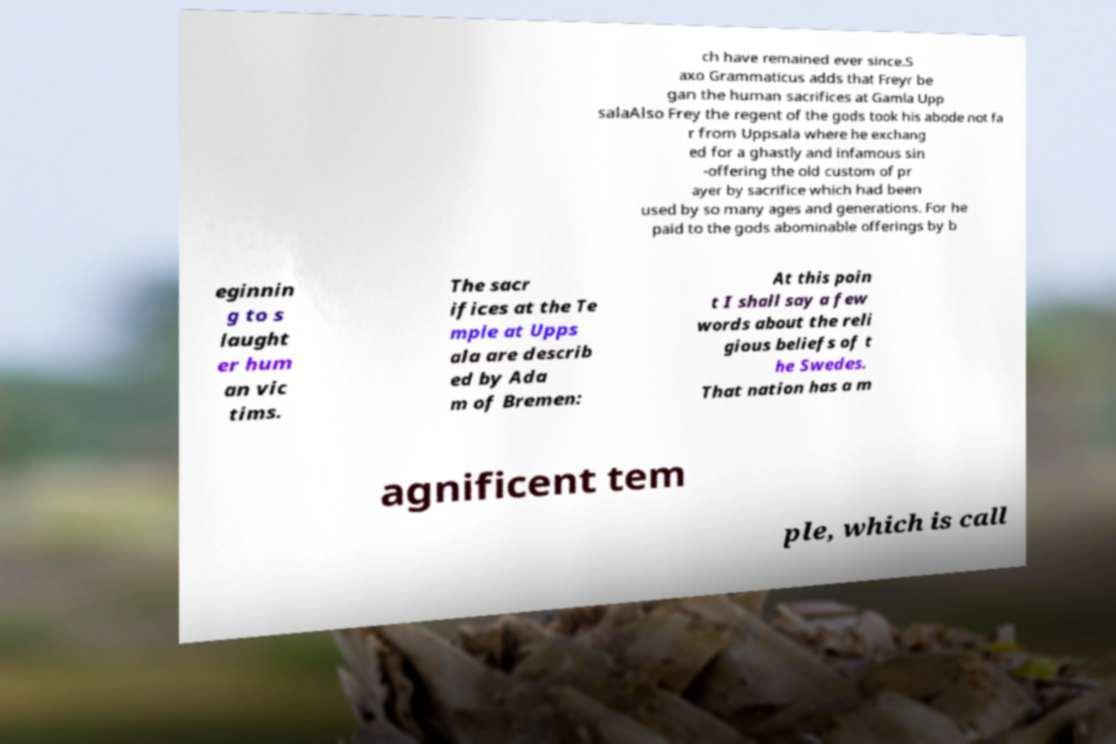Can you accurately transcribe the text from the provided image for me? ch have remained ever since.S axo Grammaticus adds that Freyr be gan the human sacrifices at Gamla Upp salaAlso Frey the regent of the gods took his abode not fa r from Uppsala where he exchang ed for a ghastly and infamous sin -offering the old custom of pr ayer by sacrifice which had been used by so many ages and generations. For he paid to the gods abominable offerings by b eginnin g to s laught er hum an vic tims. The sacr ifices at the Te mple at Upps ala are describ ed by Ada m of Bremen: At this poin t I shall say a few words about the reli gious beliefs of t he Swedes. That nation has a m agnificent tem ple, which is call 